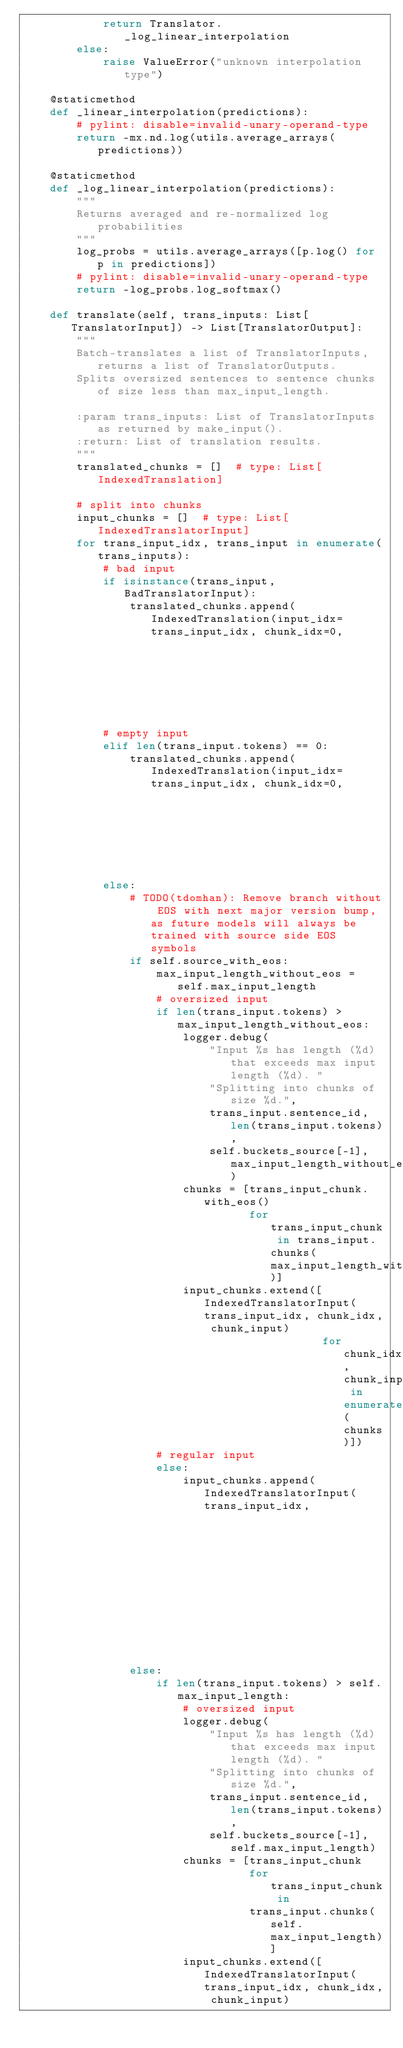Convert code to text. <code><loc_0><loc_0><loc_500><loc_500><_Python_>            return Translator._log_linear_interpolation
        else:
            raise ValueError("unknown interpolation type")

    @staticmethod
    def _linear_interpolation(predictions):
        # pylint: disable=invalid-unary-operand-type
        return -mx.nd.log(utils.average_arrays(predictions))

    @staticmethod
    def _log_linear_interpolation(predictions):
        """
        Returns averaged and re-normalized log probabilities
        """
        log_probs = utils.average_arrays([p.log() for p in predictions])
        # pylint: disable=invalid-unary-operand-type
        return -log_probs.log_softmax()

    def translate(self, trans_inputs: List[TranslatorInput]) -> List[TranslatorOutput]:
        """
        Batch-translates a list of TranslatorInputs, returns a list of TranslatorOutputs.
        Splits oversized sentences to sentence chunks of size less than max_input_length.

        :param trans_inputs: List of TranslatorInputs as returned by make_input().
        :return: List of translation results.
        """
        translated_chunks = []  # type: List[IndexedTranslation]

        # split into chunks
        input_chunks = []  # type: List[IndexedTranslatorInput]
        for trans_input_idx, trans_input in enumerate(trans_inputs):
            # bad input
            if isinstance(trans_input, BadTranslatorInput):
                translated_chunks.append(IndexedTranslation(input_idx=trans_input_idx, chunk_idx=0,
                                                            translation=empty_translation()))
            # empty input
            elif len(trans_input.tokens) == 0:
                translated_chunks.append(IndexedTranslation(input_idx=trans_input_idx, chunk_idx=0,
                                                            translation=empty_translation()))
            else:
                # TODO(tdomhan): Remove branch without EOS with next major version bump, as future models will always be trained with source side EOS symbols
                if self.source_with_eos:
                    max_input_length_without_eos = self.max_input_length
                    # oversized input
                    if len(trans_input.tokens) > max_input_length_without_eos:
                        logger.debug(
                            "Input %s has length (%d) that exceeds max input length (%d). "
                            "Splitting into chunks of size %d.",
                            trans_input.sentence_id, len(trans_input.tokens),
                            self.buckets_source[-1], max_input_length_without_eos)
                        chunks = [trans_input_chunk.with_eos()
                                  for trans_input_chunk in trans_input.chunks(max_input_length_without_eos)]
                        input_chunks.extend([IndexedTranslatorInput(trans_input_idx, chunk_idx, chunk_input)
                                             for chunk_idx, chunk_input in enumerate(chunks)])
                    # regular input
                    else:
                        input_chunks.append(IndexedTranslatorInput(trans_input_idx,
                                                                   chunk_idx=0,
                                                                   translator_input=trans_input.with_eos()))
                else:
                    if len(trans_input.tokens) > self.max_input_length:
                        # oversized input
                        logger.debug(
                            "Input %s has length (%d) that exceeds max input length (%d). "
                            "Splitting into chunks of size %d.",
                            trans_input.sentence_id, len(trans_input.tokens),
                            self.buckets_source[-1], self.max_input_length)
                        chunks = [trans_input_chunk
                                  for trans_input_chunk in
                                  trans_input.chunks(self.max_input_length)]
                        input_chunks.extend([IndexedTranslatorInput(trans_input_idx, chunk_idx, chunk_input)</code> 